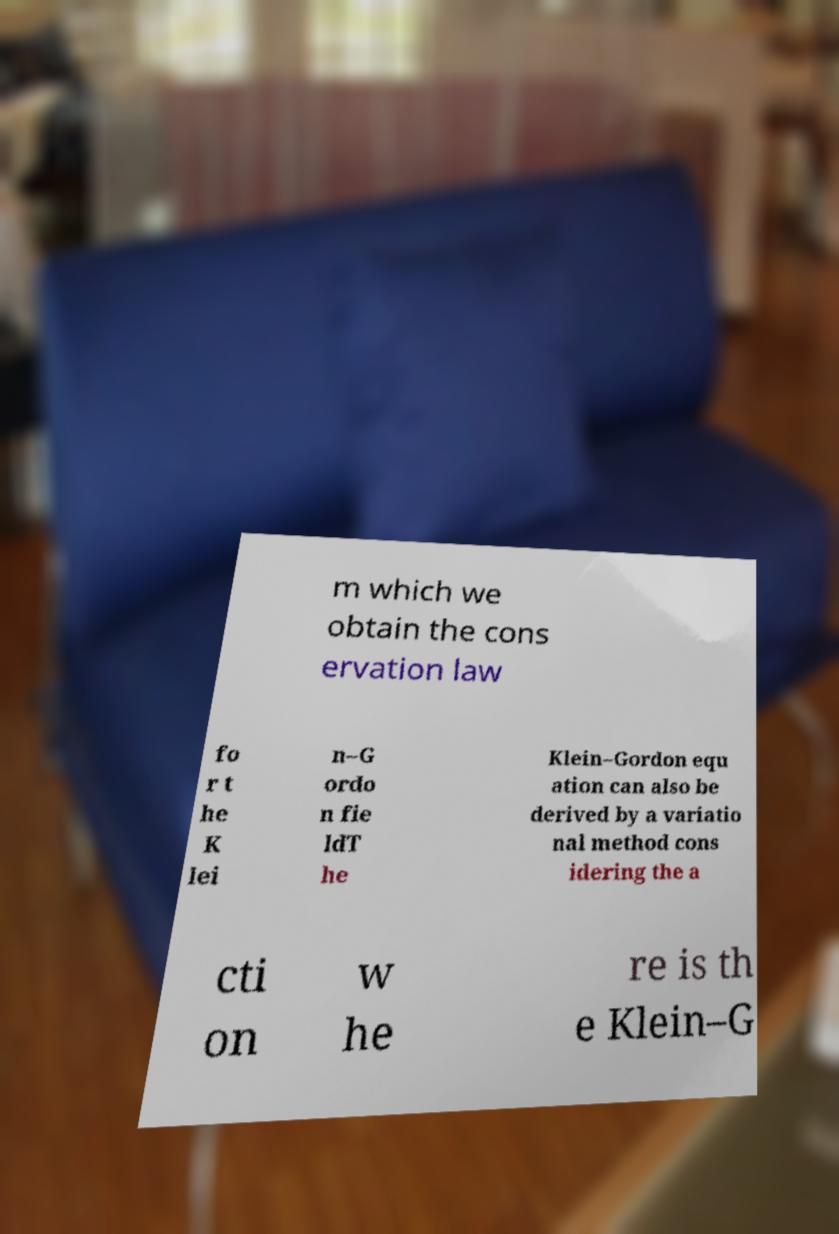Can you accurately transcribe the text from the provided image for me? m which we obtain the cons ervation law fo r t he K lei n–G ordo n fie ldT he Klein–Gordon equ ation can also be derived by a variatio nal method cons idering the a cti on w he re is th e Klein–G 